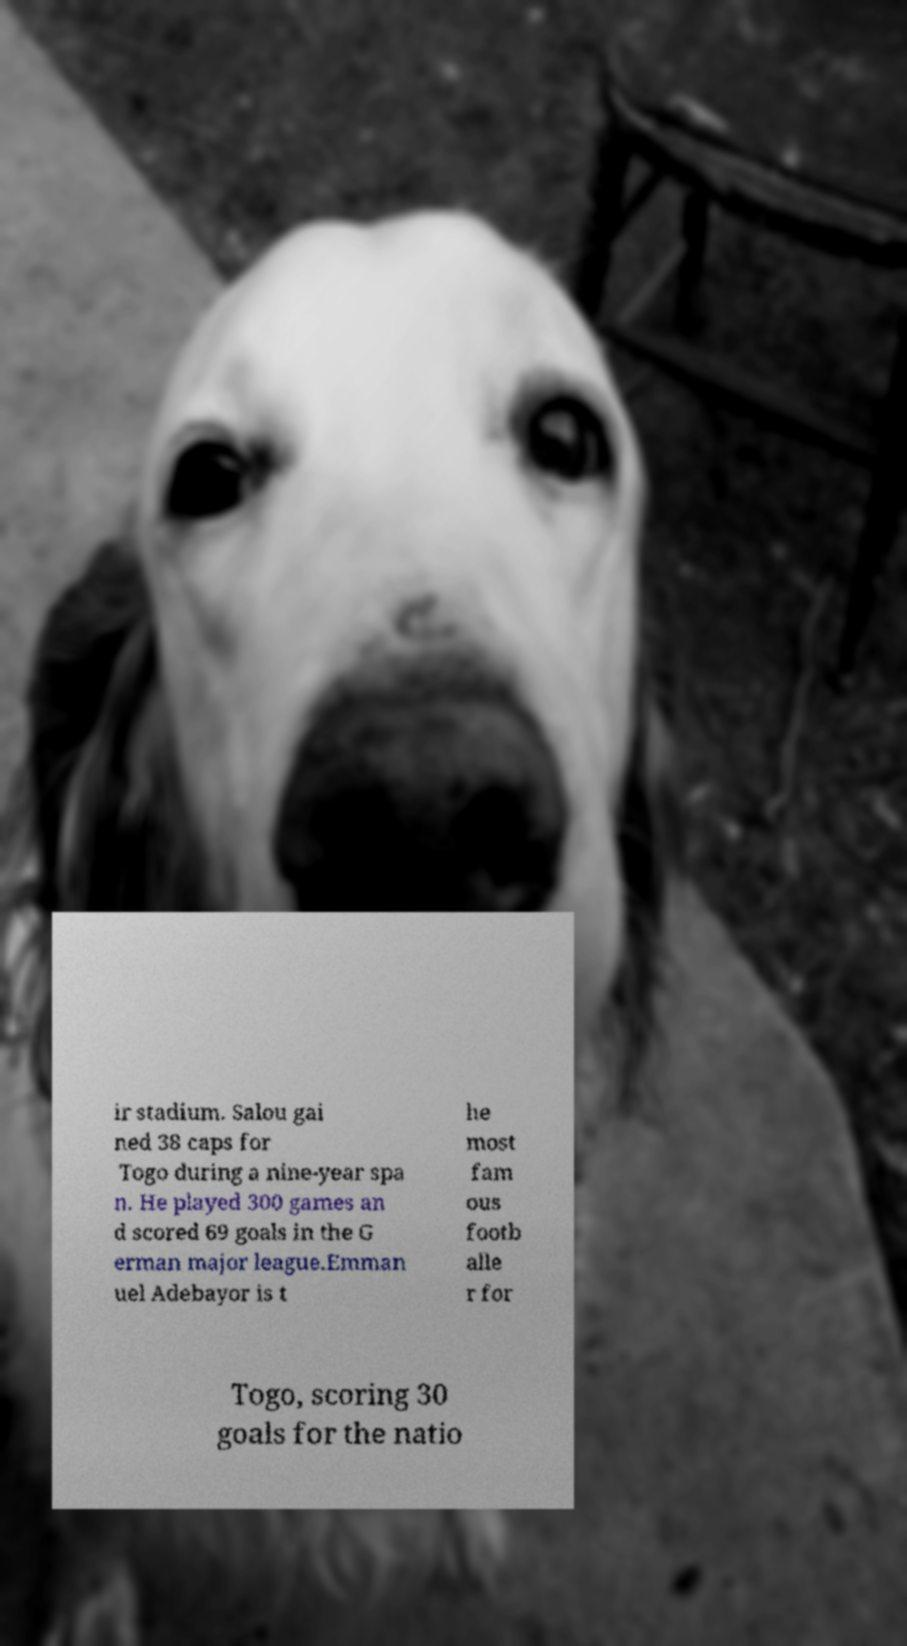Could you assist in decoding the text presented in this image and type it out clearly? ir stadium. Salou gai ned 38 caps for Togo during a nine-year spa n. He played 300 games an d scored 69 goals in the G erman major league.Emman uel Adebayor is t he most fam ous footb alle r for Togo, scoring 30 goals for the natio 